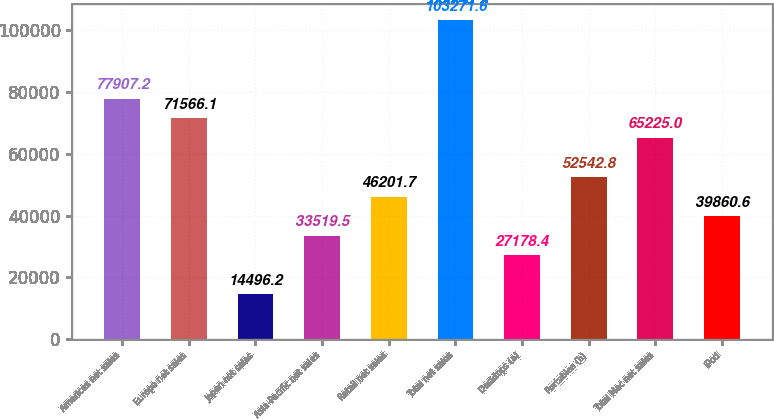Convert chart to OTSL. <chart><loc_0><loc_0><loc_500><loc_500><bar_chart><fcel>Americas net sales<fcel>Europe net sales<fcel>Japan net sales<fcel>Asia-Pacific net sales<fcel>Retail net sales<fcel>Total net sales<fcel>Desktops (a)<fcel>Portables (b)<fcel>Total Mac net sales<fcel>iPod<nl><fcel>77907.2<fcel>71566.1<fcel>14496.2<fcel>33519.5<fcel>46201.7<fcel>103272<fcel>27178.4<fcel>52542.8<fcel>65225<fcel>39860.6<nl></chart> 